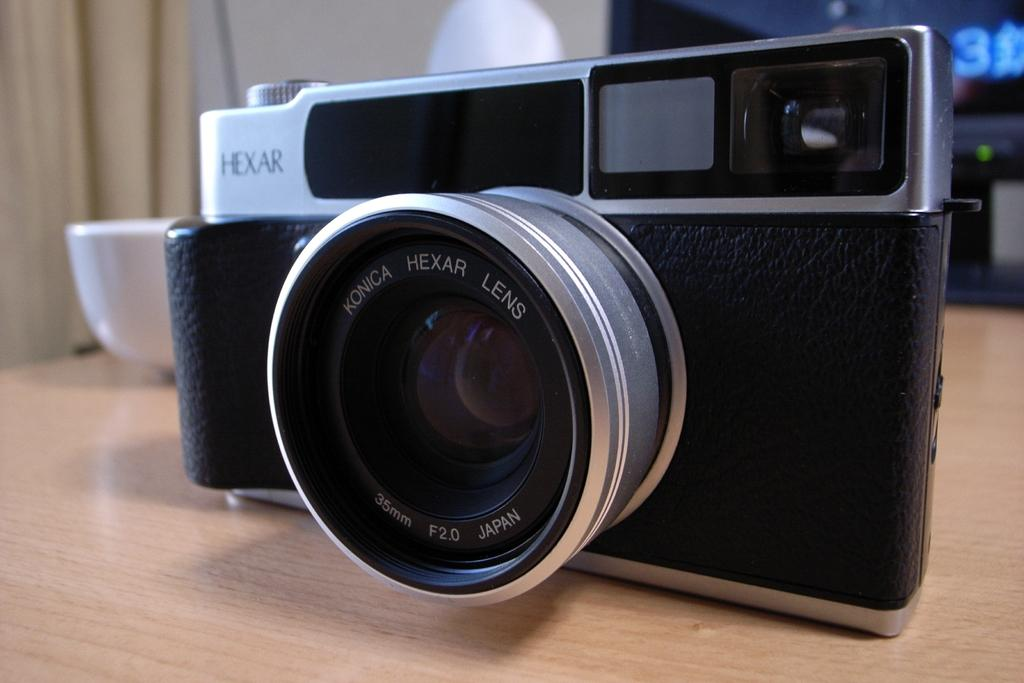What object is the main focus of the image? There is a camera in the image. Where is the camera located? The camera is on a table. What colors can be seen on the camera? The camera is black and silver in color. What can be observed about the background in the image? The background of the camera is blurred. What type of prison is visible in the background of the image? There is no prison present in the image; it features a camera on a table with a blurred background. How many calculators can be seen in the image? There are no calculators present in the image. 